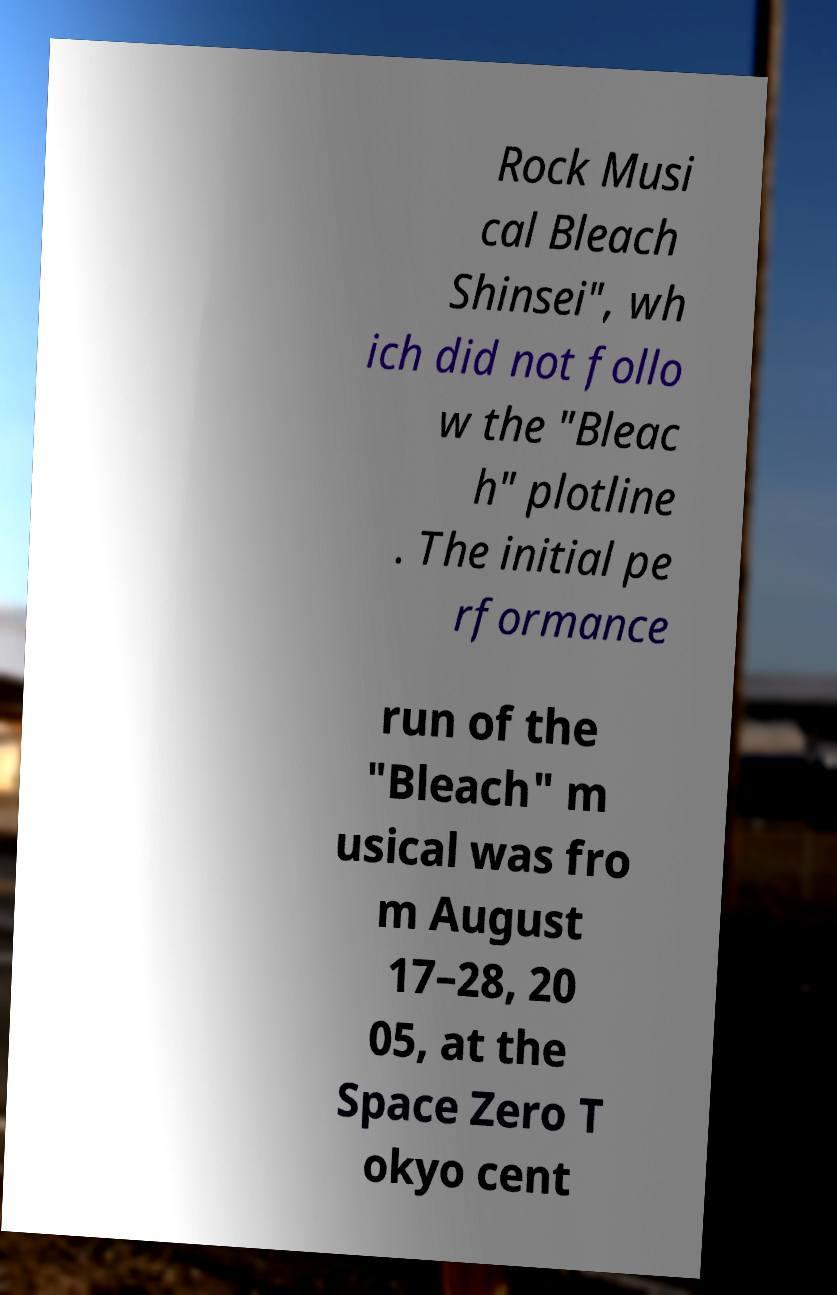Can you read and provide the text displayed in the image?This photo seems to have some interesting text. Can you extract and type it out for me? Rock Musi cal Bleach Shinsei", wh ich did not follo w the "Bleac h" plotline . The initial pe rformance run of the "Bleach" m usical was fro m August 17–28, 20 05, at the Space Zero T okyo cent 